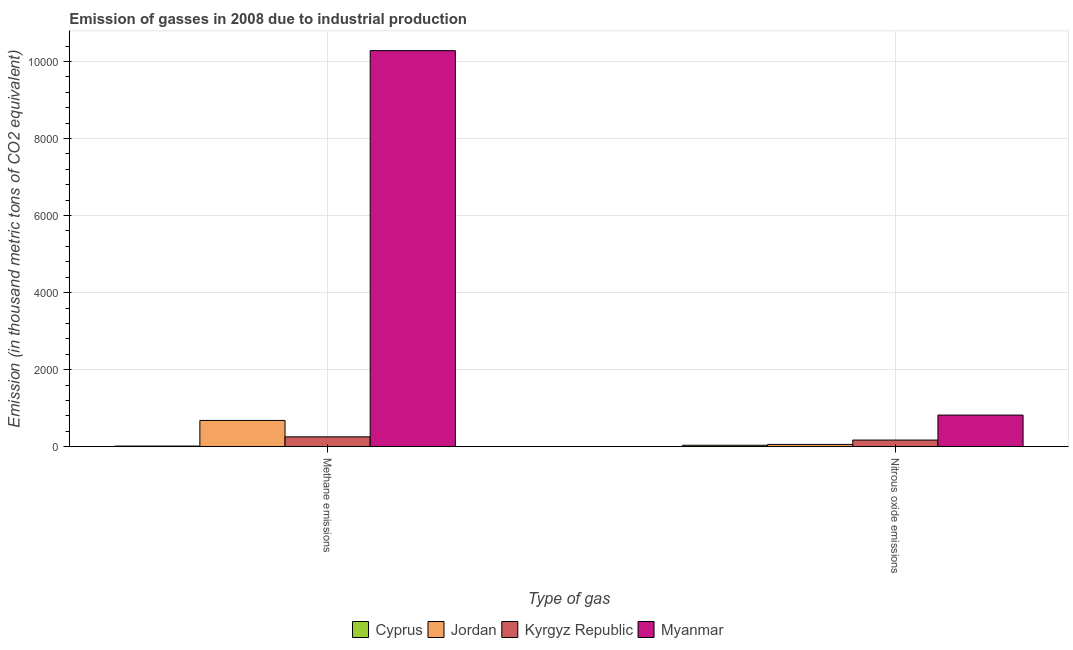Are the number of bars per tick equal to the number of legend labels?
Your answer should be very brief. Yes. Are the number of bars on each tick of the X-axis equal?
Offer a very short reply. Yes. How many bars are there on the 2nd tick from the left?
Your response must be concise. 4. What is the label of the 1st group of bars from the left?
Offer a very short reply. Methane emissions. What is the amount of methane emissions in Jordan?
Your response must be concise. 681.7. Across all countries, what is the maximum amount of nitrous oxide emissions?
Your answer should be very brief. 821.1. In which country was the amount of nitrous oxide emissions maximum?
Give a very brief answer. Myanmar. In which country was the amount of methane emissions minimum?
Your answer should be compact. Cyprus. What is the total amount of nitrous oxide emissions in the graph?
Give a very brief answer. 1089.3. What is the difference between the amount of methane emissions in Jordan and that in Cyprus?
Provide a succinct answer. 665.7. What is the difference between the amount of nitrous oxide emissions in Cyprus and the amount of methane emissions in Jordan?
Offer a very short reply. -644.1. What is the average amount of methane emissions per country?
Your answer should be compact. 2809.1. What is the difference between the amount of nitrous oxide emissions and amount of methane emissions in Kyrgyz Republic?
Ensure brevity in your answer.  -84.1. In how many countries, is the amount of nitrous oxide emissions greater than 2800 thousand metric tons?
Your response must be concise. 0. What is the ratio of the amount of nitrous oxide emissions in Jordan to that in Myanmar?
Give a very brief answer. 0.07. In how many countries, is the amount of nitrous oxide emissions greater than the average amount of nitrous oxide emissions taken over all countries?
Keep it short and to the point. 1. What does the 2nd bar from the left in Nitrous oxide emissions represents?
Keep it short and to the point. Jordan. What does the 1st bar from the right in Nitrous oxide emissions represents?
Offer a terse response. Myanmar. How many bars are there?
Ensure brevity in your answer.  8. Are all the bars in the graph horizontal?
Your answer should be very brief. No. What is the difference between two consecutive major ticks on the Y-axis?
Make the answer very short. 2000. Are the values on the major ticks of Y-axis written in scientific E-notation?
Offer a terse response. No. Does the graph contain grids?
Give a very brief answer. Yes. Where does the legend appear in the graph?
Ensure brevity in your answer.  Bottom center. How many legend labels are there?
Provide a succinct answer. 4. How are the legend labels stacked?
Offer a very short reply. Horizontal. What is the title of the graph?
Your response must be concise. Emission of gasses in 2008 due to industrial production. What is the label or title of the X-axis?
Offer a very short reply. Type of gas. What is the label or title of the Y-axis?
Your answer should be compact. Emission (in thousand metric tons of CO2 equivalent). What is the Emission (in thousand metric tons of CO2 equivalent) in Cyprus in Methane emissions?
Give a very brief answer. 16. What is the Emission (in thousand metric tons of CO2 equivalent) of Jordan in Methane emissions?
Offer a very short reply. 681.7. What is the Emission (in thousand metric tons of CO2 equivalent) in Kyrgyz Republic in Methane emissions?
Give a very brief answer. 256. What is the Emission (in thousand metric tons of CO2 equivalent) of Myanmar in Methane emissions?
Make the answer very short. 1.03e+04. What is the Emission (in thousand metric tons of CO2 equivalent) of Cyprus in Nitrous oxide emissions?
Offer a very short reply. 37.6. What is the Emission (in thousand metric tons of CO2 equivalent) in Jordan in Nitrous oxide emissions?
Make the answer very short. 58.7. What is the Emission (in thousand metric tons of CO2 equivalent) of Kyrgyz Republic in Nitrous oxide emissions?
Provide a short and direct response. 171.9. What is the Emission (in thousand metric tons of CO2 equivalent) of Myanmar in Nitrous oxide emissions?
Make the answer very short. 821.1. Across all Type of gas, what is the maximum Emission (in thousand metric tons of CO2 equivalent) of Cyprus?
Your answer should be very brief. 37.6. Across all Type of gas, what is the maximum Emission (in thousand metric tons of CO2 equivalent) in Jordan?
Your answer should be very brief. 681.7. Across all Type of gas, what is the maximum Emission (in thousand metric tons of CO2 equivalent) of Kyrgyz Republic?
Keep it short and to the point. 256. Across all Type of gas, what is the maximum Emission (in thousand metric tons of CO2 equivalent) in Myanmar?
Ensure brevity in your answer.  1.03e+04. Across all Type of gas, what is the minimum Emission (in thousand metric tons of CO2 equivalent) of Jordan?
Make the answer very short. 58.7. Across all Type of gas, what is the minimum Emission (in thousand metric tons of CO2 equivalent) in Kyrgyz Republic?
Provide a short and direct response. 171.9. Across all Type of gas, what is the minimum Emission (in thousand metric tons of CO2 equivalent) in Myanmar?
Your answer should be very brief. 821.1. What is the total Emission (in thousand metric tons of CO2 equivalent) of Cyprus in the graph?
Offer a very short reply. 53.6. What is the total Emission (in thousand metric tons of CO2 equivalent) in Jordan in the graph?
Provide a short and direct response. 740.4. What is the total Emission (in thousand metric tons of CO2 equivalent) in Kyrgyz Republic in the graph?
Ensure brevity in your answer.  427.9. What is the total Emission (in thousand metric tons of CO2 equivalent) of Myanmar in the graph?
Provide a short and direct response. 1.11e+04. What is the difference between the Emission (in thousand metric tons of CO2 equivalent) in Cyprus in Methane emissions and that in Nitrous oxide emissions?
Ensure brevity in your answer.  -21.6. What is the difference between the Emission (in thousand metric tons of CO2 equivalent) in Jordan in Methane emissions and that in Nitrous oxide emissions?
Your answer should be very brief. 623. What is the difference between the Emission (in thousand metric tons of CO2 equivalent) in Kyrgyz Republic in Methane emissions and that in Nitrous oxide emissions?
Your response must be concise. 84.1. What is the difference between the Emission (in thousand metric tons of CO2 equivalent) in Myanmar in Methane emissions and that in Nitrous oxide emissions?
Ensure brevity in your answer.  9461.6. What is the difference between the Emission (in thousand metric tons of CO2 equivalent) in Cyprus in Methane emissions and the Emission (in thousand metric tons of CO2 equivalent) in Jordan in Nitrous oxide emissions?
Make the answer very short. -42.7. What is the difference between the Emission (in thousand metric tons of CO2 equivalent) in Cyprus in Methane emissions and the Emission (in thousand metric tons of CO2 equivalent) in Kyrgyz Republic in Nitrous oxide emissions?
Offer a very short reply. -155.9. What is the difference between the Emission (in thousand metric tons of CO2 equivalent) in Cyprus in Methane emissions and the Emission (in thousand metric tons of CO2 equivalent) in Myanmar in Nitrous oxide emissions?
Provide a succinct answer. -805.1. What is the difference between the Emission (in thousand metric tons of CO2 equivalent) of Jordan in Methane emissions and the Emission (in thousand metric tons of CO2 equivalent) of Kyrgyz Republic in Nitrous oxide emissions?
Your answer should be very brief. 509.8. What is the difference between the Emission (in thousand metric tons of CO2 equivalent) of Jordan in Methane emissions and the Emission (in thousand metric tons of CO2 equivalent) of Myanmar in Nitrous oxide emissions?
Provide a succinct answer. -139.4. What is the difference between the Emission (in thousand metric tons of CO2 equivalent) of Kyrgyz Republic in Methane emissions and the Emission (in thousand metric tons of CO2 equivalent) of Myanmar in Nitrous oxide emissions?
Offer a very short reply. -565.1. What is the average Emission (in thousand metric tons of CO2 equivalent) of Cyprus per Type of gas?
Your answer should be very brief. 26.8. What is the average Emission (in thousand metric tons of CO2 equivalent) of Jordan per Type of gas?
Ensure brevity in your answer.  370.2. What is the average Emission (in thousand metric tons of CO2 equivalent) of Kyrgyz Republic per Type of gas?
Offer a very short reply. 213.95. What is the average Emission (in thousand metric tons of CO2 equivalent) in Myanmar per Type of gas?
Your answer should be very brief. 5551.9. What is the difference between the Emission (in thousand metric tons of CO2 equivalent) of Cyprus and Emission (in thousand metric tons of CO2 equivalent) of Jordan in Methane emissions?
Ensure brevity in your answer.  -665.7. What is the difference between the Emission (in thousand metric tons of CO2 equivalent) of Cyprus and Emission (in thousand metric tons of CO2 equivalent) of Kyrgyz Republic in Methane emissions?
Offer a very short reply. -240. What is the difference between the Emission (in thousand metric tons of CO2 equivalent) of Cyprus and Emission (in thousand metric tons of CO2 equivalent) of Myanmar in Methane emissions?
Your answer should be very brief. -1.03e+04. What is the difference between the Emission (in thousand metric tons of CO2 equivalent) in Jordan and Emission (in thousand metric tons of CO2 equivalent) in Kyrgyz Republic in Methane emissions?
Offer a terse response. 425.7. What is the difference between the Emission (in thousand metric tons of CO2 equivalent) of Jordan and Emission (in thousand metric tons of CO2 equivalent) of Myanmar in Methane emissions?
Your answer should be very brief. -9601. What is the difference between the Emission (in thousand metric tons of CO2 equivalent) of Kyrgyz Republic and Emission (in thousand metric tons of CO2 equivalent) of Myanmar in Methane emissions?
Your response must be concise. -1.00e+04. What is the difference between the Emission (in thousand metric tons of CO2 equivalent) of Cyprus and Emission (in thousand metric tons of CO2 equivalent) of Jordan in Nitrous oxide emissions?
Your answer should be very brief. -21.1. What is the difference between the Emission (in thousand metric tons of CO2 equivalent) in Cyprus and Emission (in thousand metric tons of CO2 equivalent) in Kyrgyz Republic in Nitrous oxide emissions?
Ensure brevity in your answer.  -134.3. What is the difference between the Emission (in thousand metric tons of CO2 equivalent) of Cyprus and Emission (in thousand metric tons of CO2 equivalent) of Myanmar in Nitrous oxide emissions?
Provide a short and direct response. -783.5. What is the difference between the Emission (in thousand metric tons of CO2 equivalent) of Jordan and Emission (in thousand metric tons of CO2 equivalent) of Kyrgyz Republic in Nitrous oxide emissions?
Provide a succinct answer. -113.2. What is the difference between the Emission (in thousand metric tons of CO2 equivalent) in Jordan and Emission (in thousand metric tons of CO2 equivalent) in Myanmar in Nitrous oxide emissions?
Ensure brevity in your answer.  -762.4. What is the difference between the Emission (in thousand metric tons of CO2 equivalent) in Kyrgyz Republic and Emission (in thousand metric tons of CO2 equivalent) in Myanmar in Nitrous oxide emissions?
Offer a very short reply. -649.2. What is the ratio of the Emission (in thousand metric tons of CO2 equivalent) in Cyprus in Methane emissions to that in Nitrous oxide emissions?
Provide a short and direct response. 0.43. What is the ratio of the Emission (in thousand metric tons of CO2 equivalent) of Jordan in Methane emissions to that in Nitrous oxide emissions?
Provide a succinct answer. 11.61. What is the ratio of the Emission (in thousand metric tons of CO2 equivalent) of Kyrgyz Republic in Methane emissions to that in Nitrous oxide emissions?
Provide a short and direct response. 1.49. What is the ratio of the Emission (in thousand metric tons of CO2 equivalent) in Myanmar in Methane emissions to that in Nitrous oxide emissions?
Keep it short and to the point. 12.52. What is the difference between the highest and the second highest Emission (in thousand metric tons of CO2 equivalent) in Cyprus?
Provide a succinct answer. 21.6. What is the difference between the highest and the second highest Emission (in thousand metric tons of CO2 equivalent) in Jordan?
Provide a succinct answer. 623. What is the difference between the highest and the second highest Emission (in thousand metric tons of CO2 equivalent) in Kyrgyz Republic?
Give a very brief answer. 84.1. What is the difference between the highest and the second highest Emission (in thousand metric tons of CO2 equivalent) of Myanmar?
Your response must be concise. 9461.6. What is the difference between the highest and the lowest Emission (in thousand metric tons of CO2 equivalent) in Cyprus?
Make the answer very short. 21.6. What is the difference between the highest and the lowest Emission (in thousand metric tons of CO2 equivalent) of Jordan?
Make the answer very short. 623. What is the difference between the highest and the lowest Emission (in thousand metric tons of CO2 equivalent) of Kyrgyz Republic?
Your response must be concise. 84.1. What is the difference between the highest and the lowest Emission (in thousand metric tons of CO2 equivalent) in Myanmar?
Provide a short and direct response. 9461.6. 